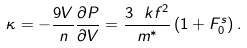<formula> <loc_0><loc_0><loc_500><loc_500>\kappa = - \frac { 9 V } { n } \frac { \partial P } { \partial V } = \frac { 3 \ k f ^ { 2 } } { m ^ { * } } \, ( 1 + F _ { 0 } ^ { s } ) \, .</formula> 